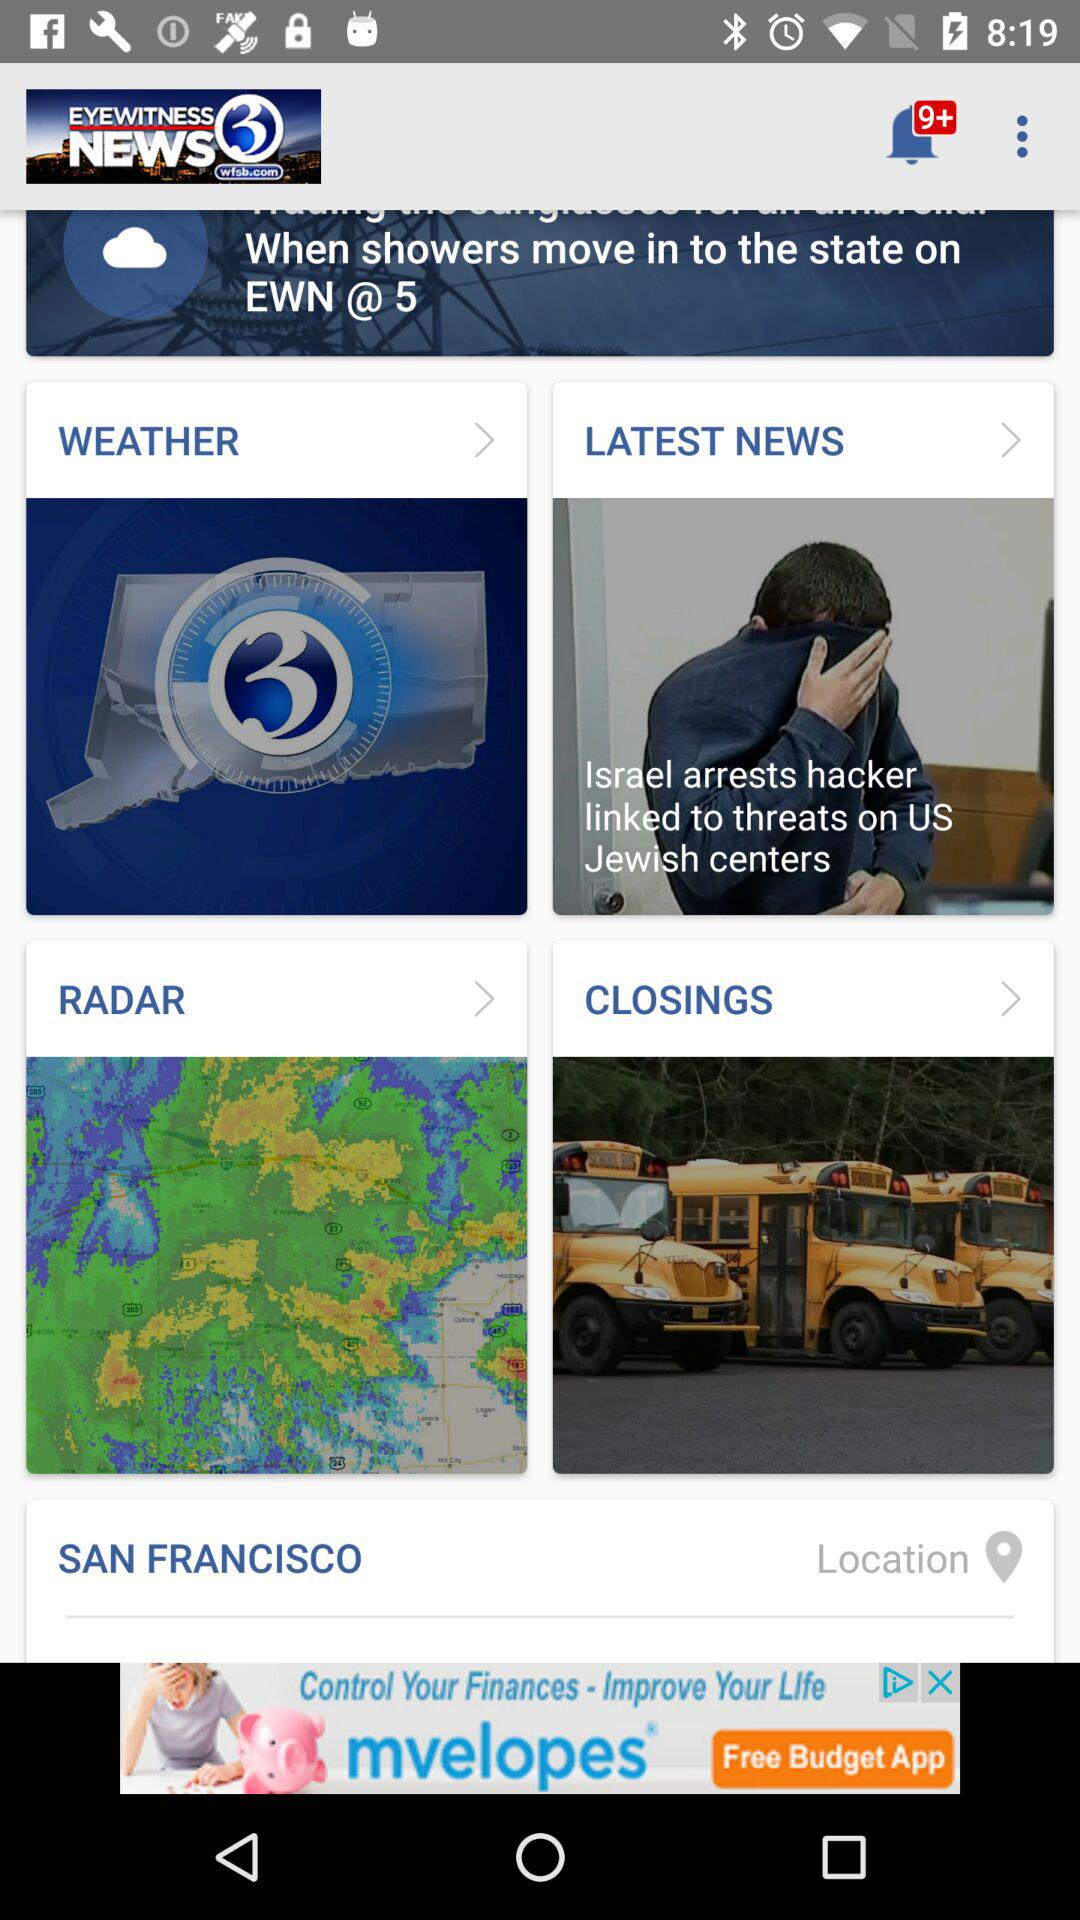What is the location? The location is San Francisco. 